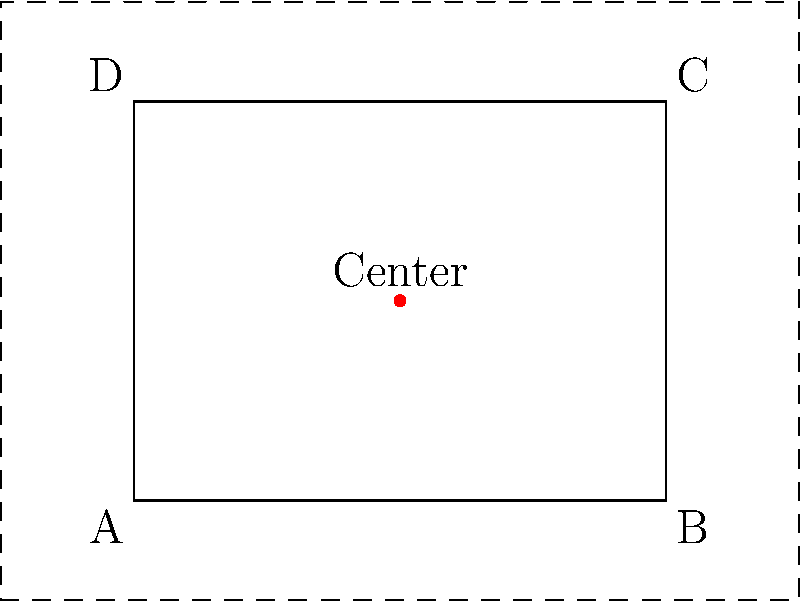In responsive design, you need to scale a rectangular UI element uniformly from its center point. The original rectangle has corners at $(0,0)$, $(4,0)$, $(4,3)$, and $(0,3)$, with its center at $(2,1.5)$. If you scale the rectangle by a factor of 1.5, what will be the coordinates of the top-right corner of the scaled rectangle? To solve this problem, we'll follow these steps:

1) First, identify the center point and the point we need to scale:
   Center: $(2, 1.5)$
   Original top-right corner (C): $(4, 3)$

2) To scale a point from a center:
   New point = Scale factor * (Original point - Center) + Center

3) Let's break this down:
   a) Original point - Center: 
      $(4, 3) - (2, 1.5) = (2, 1.5)$

   b) Multiply by scale factor:
      $1.5 * (2, 1.5) = (3, 2.25)$

   c) Add the center back:
      $(3, 2.25) + (2, 1.5) = (5, 3.75)$

4) Therefore, the new coordinates of the top-right corner are $(5, 3.75)$.
Answer: $(5, 3.75)$ 